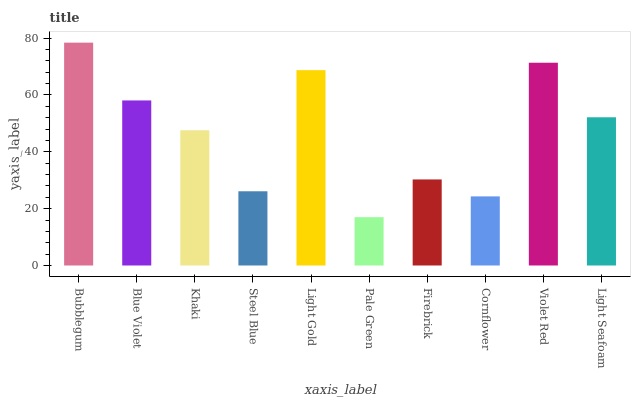Is Pale Green the minimum?
Answer yes or no. Yes. Is Bubblegum the maximum?
Answer yes or no. Yes. Is Blue Violet the minimum?
Answer yes or no. No. Is Blue Violet the maximum?
Answer yes or no. No. Is Bubblegum greater than Blue Violet?
Answer yes or no. Yes. Is Blue Violet less than Bubblegum?
Answer yes or no. Yes. Is Blue Violet greater than Bubblegum?
Answer yes or no. No. Is Bubblegum less than Blue Violet?
Answer yes or no. No. Is Light Seafoam the high median?
Answer yes or no. Yes. Is Khaki the low median?
Answer yes or no. Yes. Is Pale Green the high median?
Answer yes or no. No. Is Blue Violet the low median?
Answer yes or no. No. 